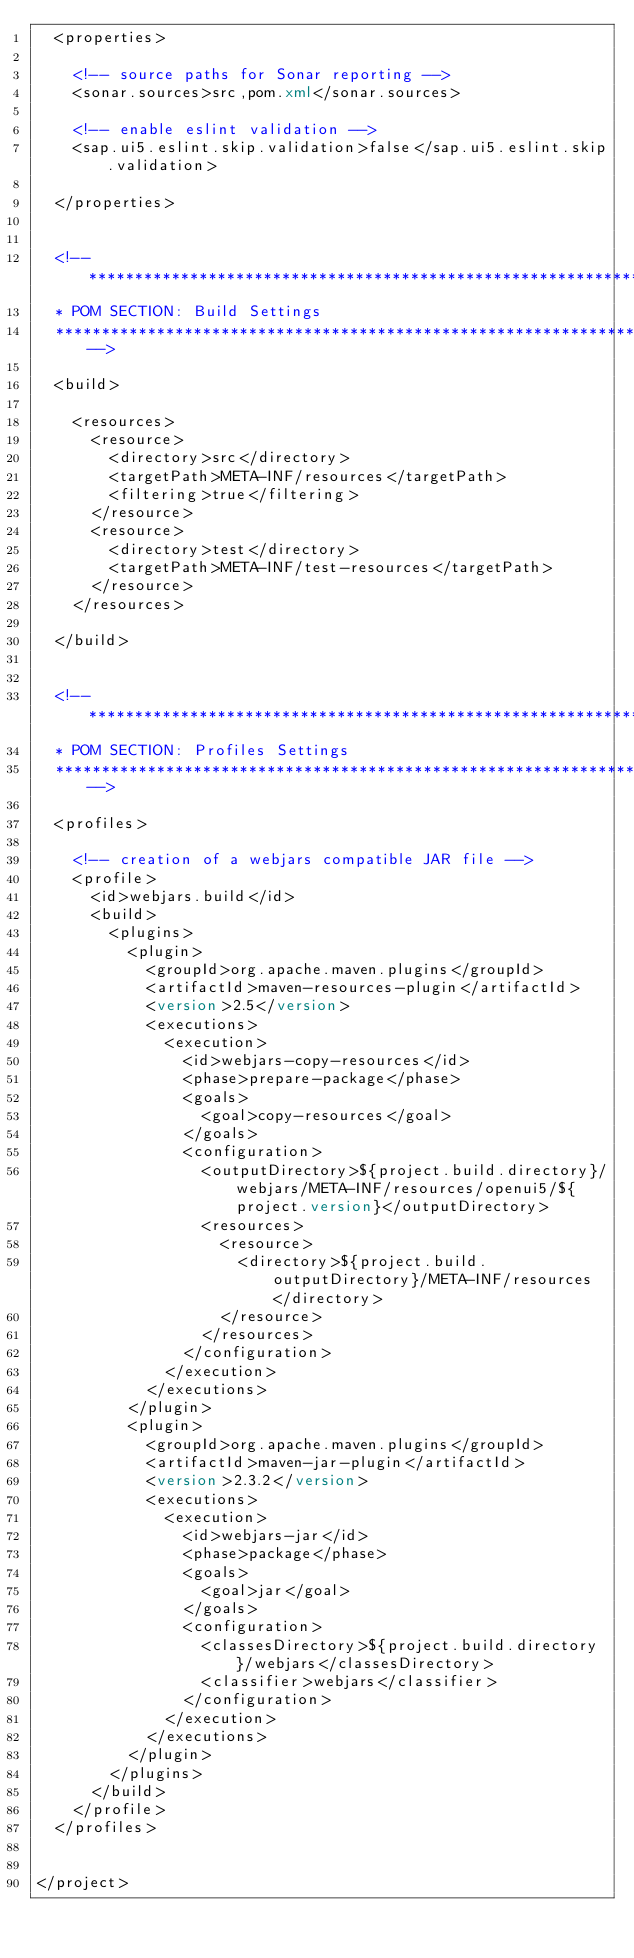Convert code to text. <code><loc_0><loc_0><loc_500><loc_500><_XML_>	<properties>

		<!-- source paths for Sonar reporting -->
		<sonar.sources>src,pom.xml</sonar.sources>

		<!-- enable eslint validation -->
		<sap.ui5.eslint.skip.validation>false</sap.ui5.eslint.skip.validation>

	</properties>


	<!--**************************************************************************
	* POM SECTION: Build Settings
	***************************************************************************-->

	<build>

		<resources>
			<resource>
				<directory>src</directory>
				<targetPath>META-INF/resources</targetPath>
				<filtering>true</filtering>
			</resource>
			<resource>
				<directory>test</directory>
				<targetPath>META-INF/test-resources</targetPath>
			</resource>
		</resources>

	</build>


	<!--**************************************************************************
	* POM SECTION: Profiles Settings
	***************************************************************************-->

	<profiles>

		<!-- creation of a webjars compatible JAR file -->
		<profile>
			<id>webjars.build</id>
			<build>
				<plugins>
					<plugin>
						<groupId>org.apache.maven.plugins</groupId>
						<artifactId>maven-resources-plugin</artifactId>
						<version>2.5</version>
						<executions>
							<execution>
								<id>webjars-copy-resources</id>
								<phase>prepare-package</phase>
								<goals>
									<goal>copy-resources</goal>
								</goals>
								<configuration>
									<outputDirectory>${project.build.directory}/webjars/META-INF/resources/openui5/${project.version}</outputDirectory>
									<resources>
										<resource>
											<directory>${project.build.outputDirectory}/META-INF/resources</directory>
										</resource>
									</resources>
								</configuration>
							</execution>
						</executions>
					</plugin>
					<plugin>
						<groupId>org.apache.maven.plugins</groupId>
						<artifactId>maven-jar-plugin</artifactId>
						<version>2.3.2</version>
						<executions>
							<execution>
								<id>webjars-jar</id>
								<phase>package</phase>
								<goals>
									<goal>jar</goal>
								</goals>
								<configuration>
									<classesDirectory>${project.build.directory}/webjars</classesDirectory>
									<classifier>webjars</classifier>
								</configuration>
							</execution>
						</executions>
					</plugin>
				</plugins>
			</build>
		</profile>
	</profiles>


</project>
</code> 